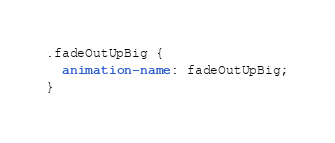Convert code to text. <code><loc_0><loc_0><loc_500><loc_500><_CSS_>
.fadeOutUpBig {
  animation-name: fadeOutUpBig;
}
</code> 